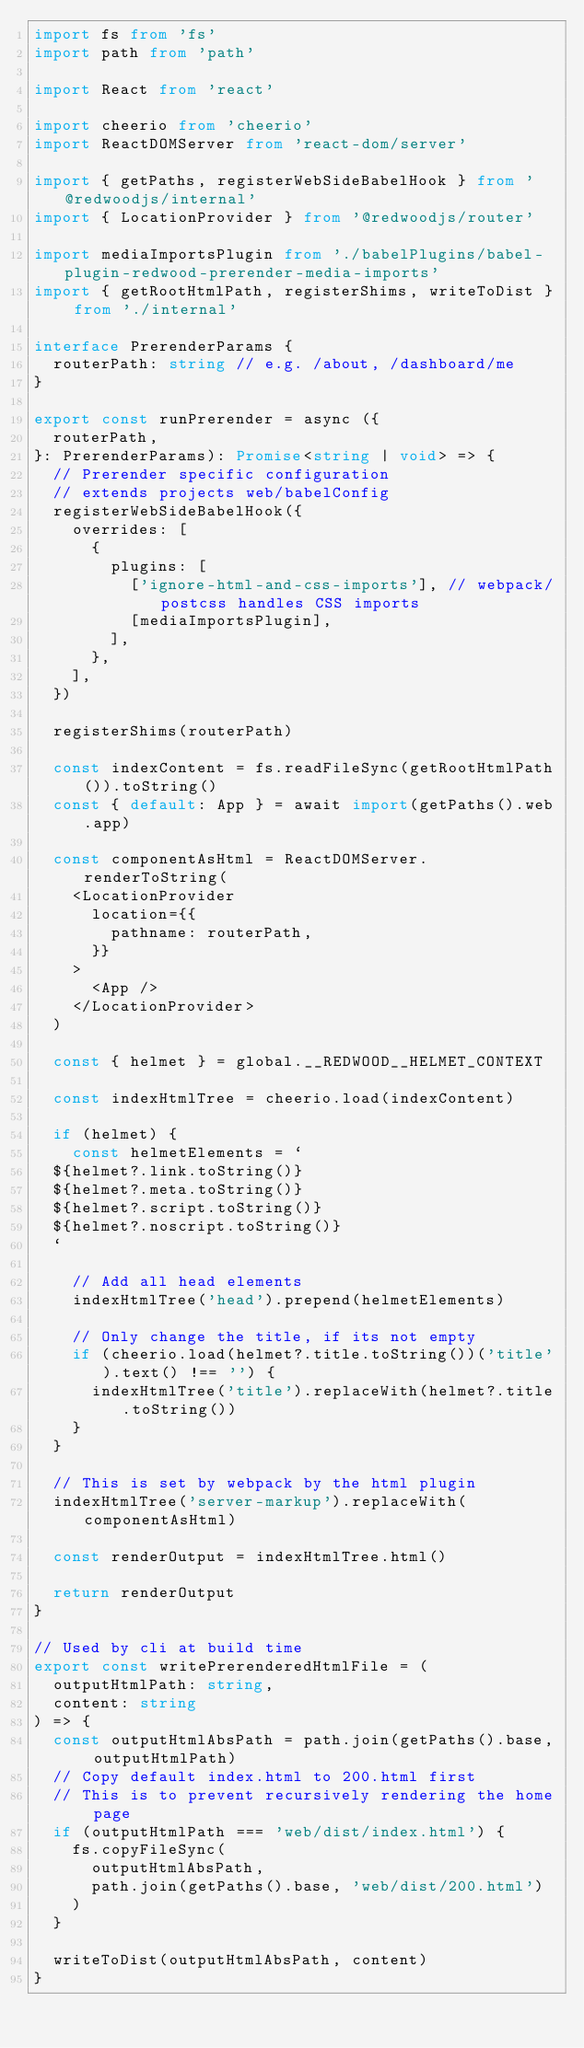Convert code to text. <code><loc_0><loc_0><loc_500><loc_500><_TypeScript_>import fs from 'fs'
import path from 'path'

import React from 'react'

import cheerio from 'cheerio'
import ReactDOMServer from 'react-dom/server'

import { getPaths, registerWebSideBabelHook } from '@redwoodjs/internal'
import { LocationProvider } from '@redwoodjs/router'

import mediaImportsPlugin from './babelPlugins/babel-plugin-redwood-prerender-media-imports'
import { getRootHtmlPath, registerShims, writeToDist } from './internal'

interface PrerenderParams {
  routerPath: string // e.g. /about, /dashboard/me
}

export const runPrerender = async ({
  routerPath,
}: PrerenderParams): Promise<string | void> => {
  // Prerender specific configuration
  // extends projects web/babelConfig
  registerWebSideBabelHook({
    overrides: [
      {
        plugins: [
          ['ignore-html-and-css-imports'], // webpack/postcss handles CSS imports
          [mediaImportsPlugin],
        ],
      },
    ],
  })

  registerShims(routerPath)

  const indexContent = fs.readFileSync(getRootHtmlPath()).toString()
  const { default: App } = await import(getPaths().web.app)

  const componentAsHtml = ReactDOMServer.renderToString(
    <LocationProvider
      location={{
        pathname: routerPath,
      }}
    >
      <App />
    </LocationProvider>
  )

  const { helmet } = global.__REDWOOD__HELMET_CONTEXT

  const indexHtmlTree = cheerio.load(indexContent)

  if (helmet) {
    const helmetElements = `
  ${helmet?.link.toString()}
  ${helmet?.meta.toString()}
  ${helmet?.script.toString()}
  ${helmet?.noscript.toString()}
  `

    // Add all head elements
    indexHtmlTree('head').prepend(helmetElements)

    // Only change the title, if its not empty
    if (cheerio.load(helmet?.title.toString())('title').text() !== '') {
      indexHtmlTree('title').replaceWith(helmet?.title.toString())
    }
  }

  // This is set by webpack by the html plugin
  indexHtmlTree('server-markup').replaceWith(componentAsHtml)

  const renderOutput = indexHtmlTree.html()

  return renderOutput
}

// Used by cli at build time
export const writePrerenderedHtmlFile = (
  outputHtmlPath: string,
  content: string
) => {
  const outputHtmlAbsPath = path.join(getPaths().base, outputHtmlPath)
  // Copy default index.html to 200.html first
  // This is to prevent recursively rendering the home page
  if (outputHtmlPath === 'web/dist/index.html') {
    fs.copyFileSync(
      outputHtmlAbsPath,
      path.join(getPaths().base, 'web/dist/200.html')
    )
  }

  writeToDist(outputHtmlAbsPath, content)
}
</code> 